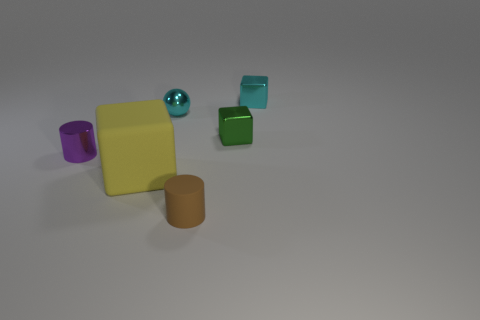How many green objects are either tiny shiny objects or small blocks?
Offer a very short reply. 1. Are there fewer tiny cyan metal balls on the right side of the cyan metal ball than small blocks in front of the tiny purple cylinder?
Your answer should be very brief. No. Is the size of the cyan metal ball the same as the cylinder in front of the shiny cylinder?
Give a very brief answer. Yes. What number of shiny spheres have the same size as the yellow matte block?
Make the answer very short. 0. What number of tiny objects are either yellow spheres or brown matte objects?
Offer a very short reply. 1. Are any big cyan shiny cubes visible?
Make the answer very short. No. Are there more small brown cylinders on the right side of the brown matte object than small brown things that are on the left side of the small cyan metal sphere?
Keep it short and to the point. No. The tiny cylinder left of the cylinder in front of the purple cylinder is what color?
Your answer should be compact. Purple. Is there a large cube that has the same color as the tiny rubber object?
Provide a short and direct response. No. There is a cyan thing that is in front of the tiny cyan object that is right of the green shiny block right of the brown rubber cylinder; what size is it?
Provide a short and direct response. Small. 